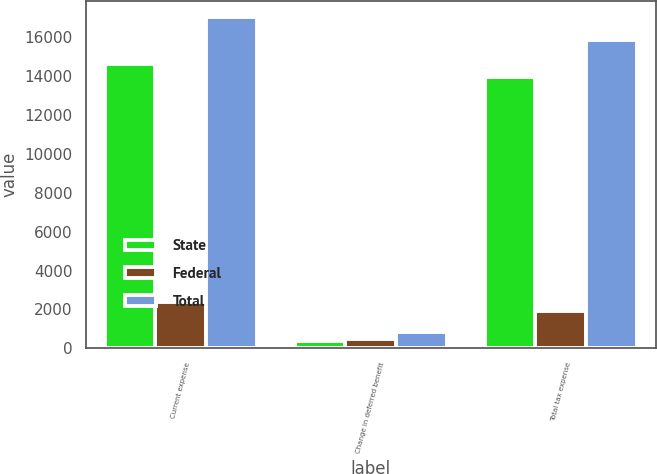Convert chart to OTSL. <chart><loc_0><loc_0><loc_500><loc_500><stacked_bar_chart><ecel><fcel>Current expense<fcel>Change in deferred benefit<fcel>Total tax expense<nl><fcel>State<fcel>14627<fcel>369<fcel>13946<nl><fcel>Federal<fcel>2368<fcel>467<fcel>1901<nl><fcel>Total<fcel>16995<fcel>836<fcel>15847<nl></chart> 